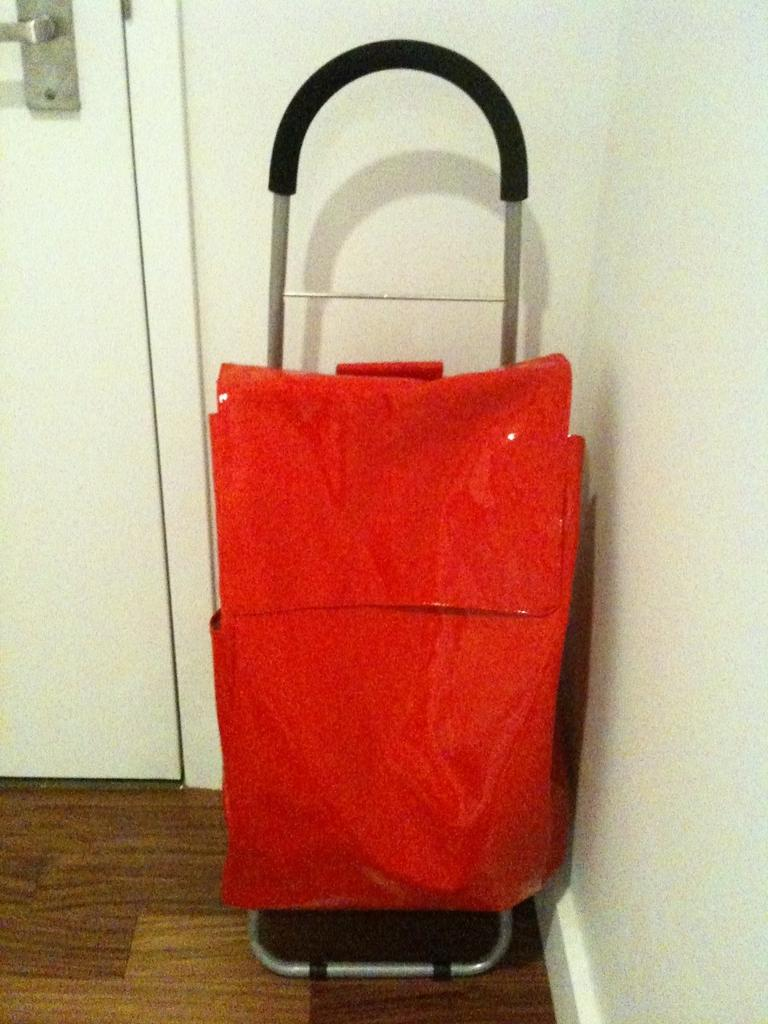What is the color of the bag in the image? The bag in the image is red. What is the bag placed on? The bag is placed on a wooden surface. What can be seen in the background of the image? There is a door and a wall in the background of the image. What direction is the bee flying in the image? There is no bee present in the image, so it cannot be determined in which direction it might be flying. 